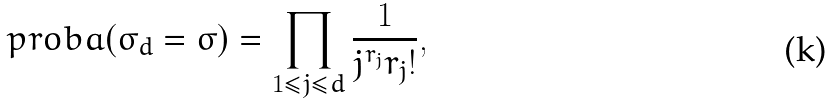<formula> <loc_0><loc_0><loc_500><loc_500>\ p r o b a ( \sigma _ { d } = \sigma ) = \prod _ { 1 \leq j \leq d } { \frac { 1 } { j ^ { r _ { j } } r _ { j } ! } } ,</formula> 